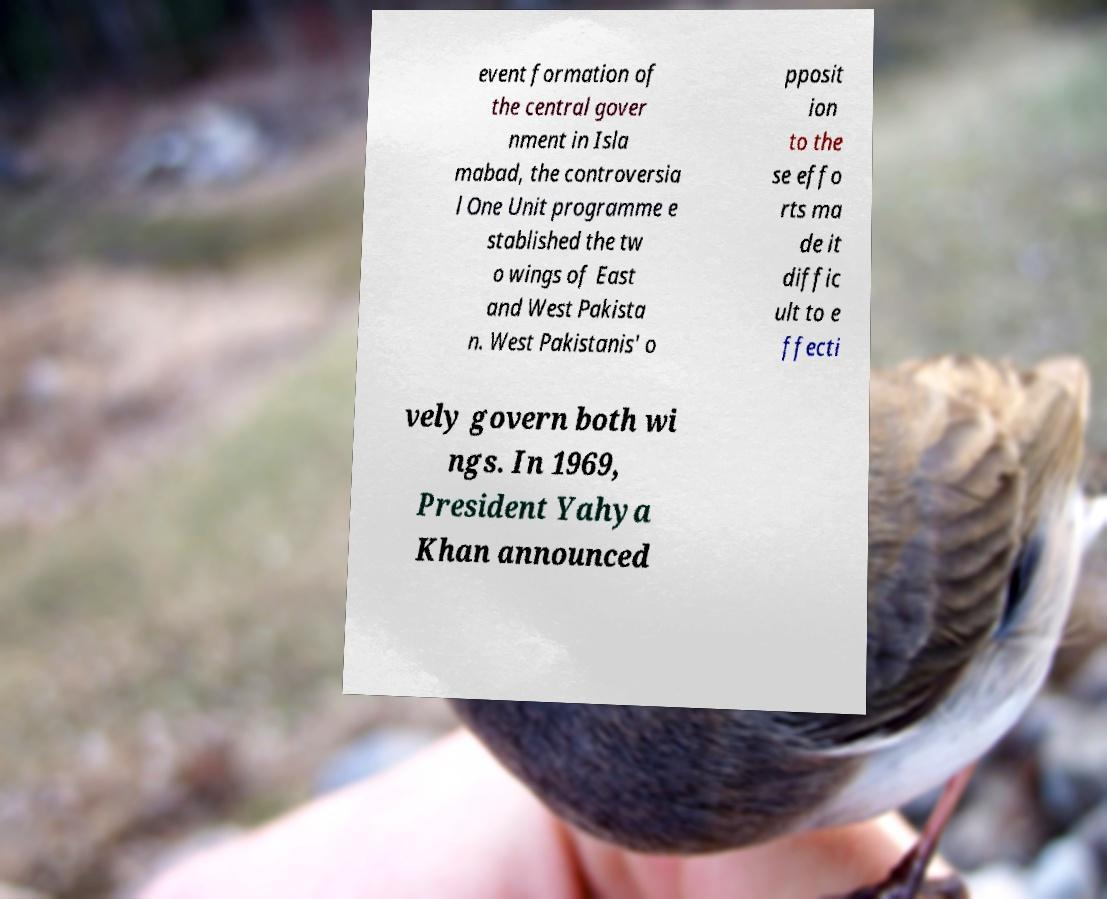Can you read and provide the text displayed in the image?This photo seems to have some interesting text. Can you extract and type it out for me? event formation of the central gover nment in Isla mabad, the controversia l One Unit programme e stablished the tw o wings of East and West Pakista n. West Pakistanis' o pposit ion to the se effo rts ma de it diffic ult to e ffecti vely govern both wi ngs. In 1969, President Yahya Khan announced 